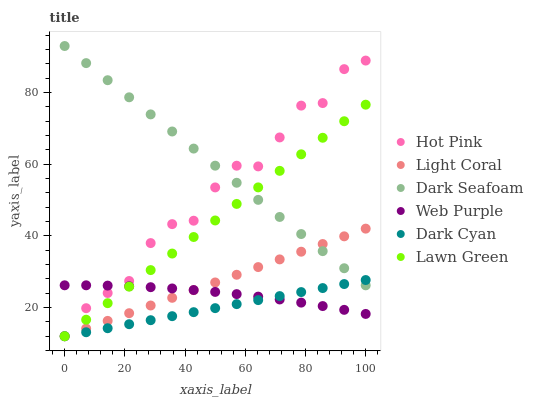Does Dark Cyan have the minimum area under the curve?
Answer yes or no. Yes. Does Dark Seafoam have the maximum area under the curve?
Answer yes or no. Yes. Does Hot Pink have the minimum area under the curve?
Answer yes or no. No. Does Hot Pink have the maximum area under the curve?
Answer yes or no. No. Is Dark Cyan the smoothest?
Answer yes or no. Yes. Is Hot Pink the roughest?
Answer yes or no. Yes. Is Web Purple the smoothest?
Answer yes or no. No. Is Web Purple the roughest?
Answer yes or no. No. Does Lawn Green have the lowest value?
Answer yes or no. Yes. Does Web Purple have the lowest value?
Answer yes or no. No. Does Dark Seafoam have the highest value?
Answer yes or no. Yes. Does Hot Pink have the highest value?
Answer yes or no. No. Is Web Purple less than Dark Seafoam?
Answer yes or no. Yes. Is Dark Seafoam greater than Web Purple?
Answer yes or no. Yes. Does Light Coral intersect Web Purple?
Answer yes or no. Yes. Is Light Coral less than Web Purple?
Answer yes or no. No. Is Light Coral greater than Web Purple?
Answer yes or no. No. Does Web Purple intersect Dark Seafoam?
Answer yes or no. No. 